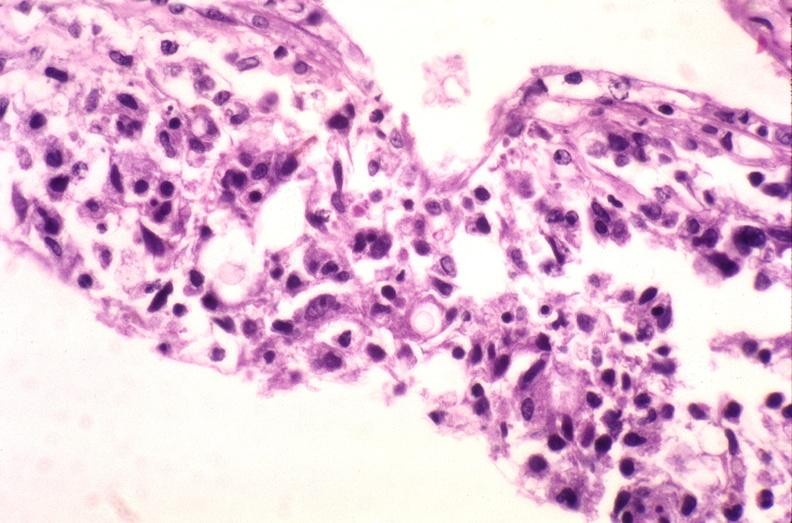s nervous present?
Answer the question using a single word or phrase. Yes 